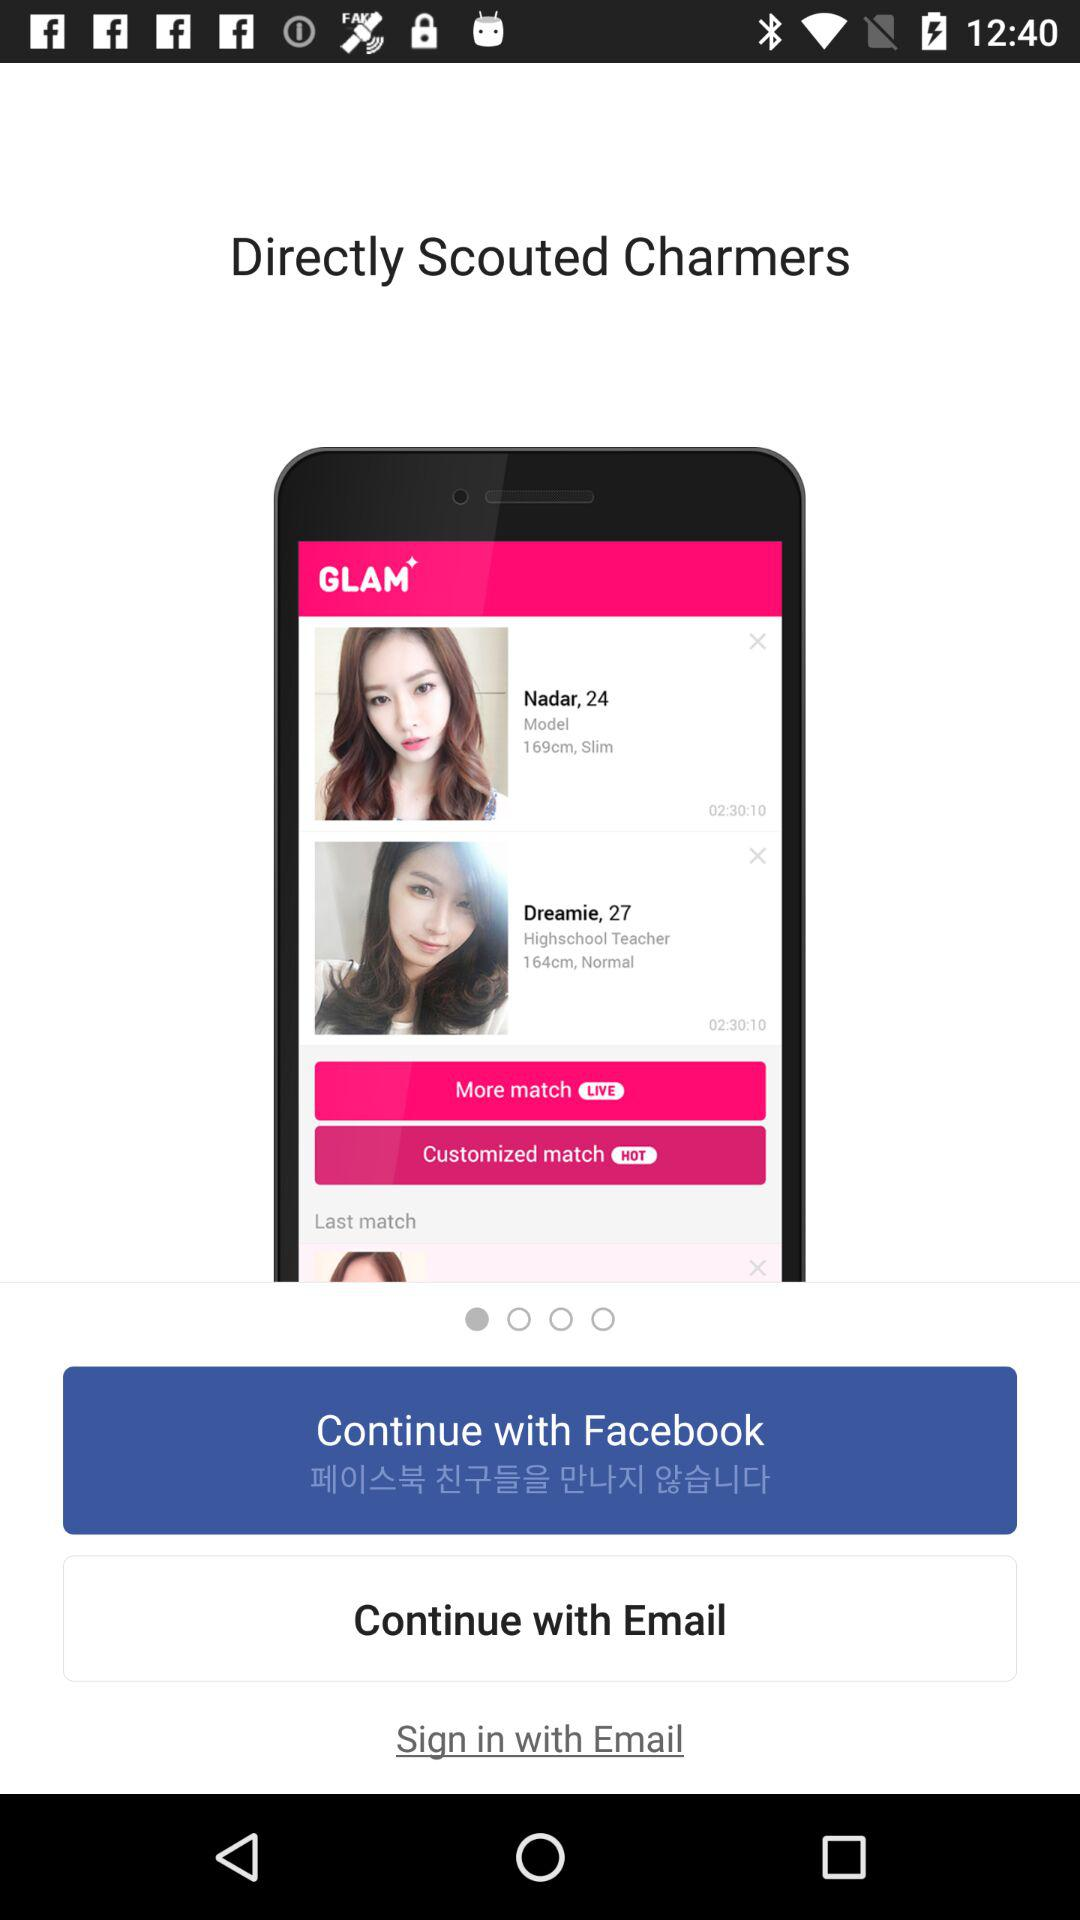Which options are available to continue with? The available options are "Facebook" and "Email". 